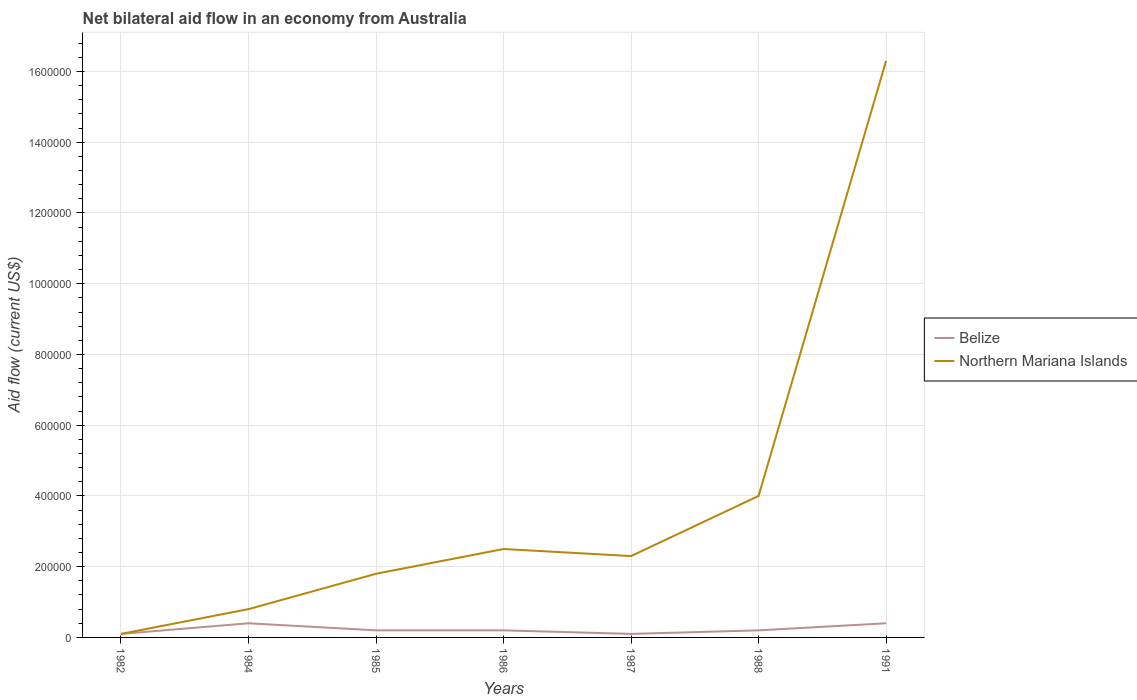How many different coloured lines are there?
Ensure brevity in your answer.  2. Is the number of lines equal to the number of legend labels?
Offer a very short reply. Yes. In which year was the net bilateral aid flow in Belize maximum?
Provide a succinct answer. 1982. What is the difference between the highest and the second highest net bilateral aid flow in Belize?
Provide a succinct answer. 3.00e+04. Is the net bilateral aid flow in Belize strictly greater than the net bilateral aid flow in Northern Mariana Islands over the years?
Your answer should be very brief. No. How many lines are there?
Offer a very short reply. 2. How many years are there in the graph?
Give a very brief answer. 7. Where does the legend appear in the graph?
Make the answer very short. Center right. How many legend labels are there?
Provide a short and direct response. 2. How are the legend labels stacked?
Ensure brevity in your answer.  Vertical. What is the title of the graph?
Provide a short and direct response. Net bilateral aid flow in an economy from Australia. Does "Romania" appear as one of the legend labels in the graph?
Your answer should be compact. No. What is the Aid flow (current US$) of Northern Mariana Islands in 1982?
Provide a succinct answer. 10000. What is the Aid flow (current US$) of Belize in 1984?
Your response must be concise. 4.00e+04. What is the Aid flow (current US$) of Belize in 1985?
Give a very brief answer. 2.00e+04. What is the Aid flow (current US$) of Belize in 1986?
Your answer should be compact. 2.00e+04. What is the Aid flow (current US$) of Northern Mariana Islands in 1986?
Your answer should be compact. 2.50e+05. What is the Aid flow (current US$) in Belize in 1987?
Make the answer very short. 10000. What is the Aid flow (current US$) in Northern Mariana Islands in 1987?
Offer a very short reply. 2.30e+05. What is the Aid flow (current US$) in Northern Mariana Islands in 1988?
Keep it short and to the point. 4.00e+05. What is the Aid flow (current US$) of Northern Mariana Islands in 1991?
Make the answer very short. 1.63e+06. Across all years, what is the maximum Aid flow (current US$) in Northern Mariana Islands?
Ensure brevity in your answer.  1.63e+06. Across all years, what is the minimum Aid flow (current US$) of Northern Mariana Islands?
Keep it short and to the point. 10000. What is the total Aid flow (current US$) of Northern Mariana Islands in the graph?
Provide a short and direct response. 2.78e+06. What is the difference between the Aid flow (current US$) of Northern Mariana Islands in 1982 and that in 1984?
Your answer should be very brief. -7.00e+04. What is the difference between the Aid flow (current US$) in Belize in 1982 and that in 1985?
Ensure brevity in your answer.  -10000. What is the difference between the Aid flow (current US$) in Belize in 1982 and that in 1986?
Your answer should be very brief. -10000. What is the difference between the Aid flow (current US$) in Northern Mariana Islands in 1982 and that in 1988?
Your response must be concise. -3.90e+05. What is the difference between the Aid flow (current US$) of Northern Mariana Islands in 1982 and that in 1991?
Provide a short and direct response. -1.62e+06. What is the difference between the Aid flow (current US$) of Northern Mariana Islands in 1984 and that in 1985?
Your response must be concise. -1.00e+05. What is the difference between the Aid flow (current US$) of Belize in 1984 and that in 1986?
Ensure brevity in your answer.  2.00e+04. What is the difference between the Aid flow (current US$) of Northern Mariana Islands in 1984 and that in 1988?
Keep it short and to the point. -3.20e+05. What is the difference between the Aid flow (current US$) of Northern Mariana Islands in 1984 and that in 1991?
Make the answer very short. -1.55e+06. What is the difference between the Aid flow (current US$) in Belize in 1985 and that in 1986?
Keep it short and to the point. 0. What is the difference between the Aid flow (current US$) of Northern Mariana Islands in 1985 and that in 1987?
Provide a short and direct response. -5.00e+04. What is the difference between the Aid flow (current US$) in Northern Mariana Islands in 1985 and that in 1988?
Keep it short and to the point. -2.20e+05. What is the difference between the Aid flow (current US$) of Belize in 1985 and that in 1991?
Ensure brevity in your answer.  -2.00e+04. What is the difference between the Aid flow (current US$) of Northern Mariana Islands in 1985 and that in 1991?
Your response must be concise. -1.45e+06. What is the difference between the Aid flow (current US$) in Belize in 1986 and that in 1987?
Give a very brief answer. 10000. What is the difference between the Aid flow (current US$) of Belize in 1986 and that in 1988?
Offer a very short reply. 0. What is the difference between the Aid flow (current US$) of Belize in 1986 and that in 1991?
Your response must be concise. -2.00e+04. What is the difference between the Aid flow (current US$) in Northern Mariana Islands in 1986 and that in 1991?
Offer a very short reply. -1.38e+06. What is the difference between the Aid flow (current US$) in Northern Mariana Islands in 1987 and that in 1988?
Give a very brief answer. -1.70e+05. What is the difference between the Aid flow (current US$) of Northern Mariana Islands in 1987 and that in 1991?
Your answer should be very brief. -1.40e+06. What is the difference between the Aid flow (current US$) in Northern Mariana Islands in 1988 and that in 1991?
Give a very brief answer. -1.23e+06. What is the difference between the Aid flow (current US$) of Belize in 1982 and the Aid flow (current US$) of Northern Mariana Islands in 1985?
Give a very brief answer. -1.70e+05. What is the difference between the Aid flow (current US$) of Belize in 1982 and the Aid flow (current US$) of Northern Mariana Islands in 1986?
Ensure brevity in your answer.  -2.40e+05. What is the difference between the Aid flow (current US$) in Belize in 1982 and the Aid flow (current US$) in Northern Mariana Islands in 1987?
Make the answer very short. -2.20e+05. What is the difference between the Aid flow (current US$) in Belize in 1982 and the Aid flow (current US$) in Northern Mariana Islands in 1988?
Make the answer very short. -3.90e+05. What is the difference between the Aid flow (current US$) of Belize in 1982 and the Aid flow (current US$) of Northern Mariana Islands in 1991?
Offer a terse response. -1.62e+06. What is the difference between the Aid flow (current US$) in Belize in 1984 and the Aid flow (current US$) in Northern Mariana Islands in 1986?
Keep it short and to the point. -2.10e+05. What is the difference between the Aid flow (current US$) of Belize in 1984 and the Aid flow (current US$) of Northern Mariana Islands in 1987?
Provide a succinct answer. -1.90e+05. What is the difference between the Aid flow (current US$) in Belize in 1984 and the Aid flow (current US$) in Northern Mariana Islands in 1988?
Your answer should be compact. -3.60e+05. What is the difference between the Aid flow (current US$) of Belize in 1984 and the Aid flow (current US$) of Northern Mariana Islands in 1991?
Give a very brief answer. -1.59e+06. What is the difference between the Aid flow (current US$) in Belize in 1985 and the Aid flow (current US$) in Northern Mariana Islands in 1988?
Make the answer very short. -3.80e+05. What is the difference between the Aid flow (current US$) in Belize in 1985 and the Aid flow (current US$) in Northern Mariana Islands in 1991?
Give a very brief answer. -1.61e+06. What is the difference between the Aid flow (current US$) of Belize in 1986 and the Aid flow (current US$) of Northern Mariana Islands in 1988?
Ensure brevity in your answer.  -3.80e+05. What is the difference between the Aid flow (current US$) of Belize in 1986 and the Aid flow (current US$) of Northern Mariana Islands in 1991?
Offer a terse response. -1.61e+06. What is the difference between the Aid flow (current US$) in Belize in 1987 and the Aid flow (current US$) in Northern Mariana Islands in 1988?
Offer a very short reply. -3.90e+05. What is the difference between the Aid flow (current US$) of Belize in 1987 and the Aid flow (current US$) of Northern Mariana Islands in 1991?
Ensure brevity in your answer.  -1.62e+06. What is the difference between the Aid flow (current US$) of Belize in 1988 and the Aid flow (current US$) of Northern Mariana Islands in 1991?
Keep it short and to the point. -1.61e+06. What is the average Aid flow (current US$) in Belize per year?
Your answer should be very brief. 2.29e+04. What is the average Aid flow (current US$) in Northern Mariana Islands per year?
Your response must be concise. 3.97e+05. In the year 1988, what is the difference between the Aid flow (current US$) of Belize and Aid flow (current US$) of Northern Mariana Islands?
Your answer should be very brief. -3.80e+05. In the year 1991, what is the difference between the Aid flow (current US$) in Belize and Aid flow (current US$) in Northern Mariana Islands?
Offer a terse response. -1.59e+06. What is the ratio of the Aid flow (current US$) in Northern Mariana Islands in 1982 to that in 1985?
Give a very brief answer. 0.06. What is the ratio of the Aid flow (current US$) in Northern Mariana Islands in 1982 to that in 1986?
Ensure brevity in your answer.  0.04. What is the ratio of the Aid flow (current US$) in Northern Mariana Islands in 1982 to that in 1987?
Your response must be concise. 0.04. What is the ratio of the Aid flow (current US$) in Northern Mariana Islands in 1982 to that in 1988?
Give a very brief answer. 0.03. What is the ratio of the Aid flow (current US$) in Northern Mariana Islands in 1982 to that in 1991?
Ensure brevity in your answer.  0.01. What is the ratio of the Aid flow (current US$) in Belize in 1984 to that in 1985?
Your answer should be compact. 2. What is the ratio of the Aid flow (current US$) in Northern Mariana Islands in 1984 to that in 1985?
Offer a terse response. 0.44. What is the ratio of the Aid flow (current US$) in Northern Mariana Islands in 1984 to that in 1986?
Your answer should be very brief. 0.32. What is the ratio of the Aid flow (current US$) of Northern Mariana Islands in 1984 to that in 1987?
Offer a very short reply. 0.35. What is the ratio of the Aid flow (current US$) of Northern Mariana Islands in 1984 to that in 1991?
Provide a succinct answer. 0.05. What is the ratio of the Aid flow (current US$) of Belize in 1985 to that in 1986?
Your answer should be very brief. 1. What is the ratio of the Aid flow (current US$) in Northern Mariana Islands in 1985 to that in 1986?
Offer a terse response. 0.72. What is the ratio of the Aid flow (current US$) of Northern Mariana Islands in 1985 to that in 1987?
Your response must be concise. 0.78. What is the ratio of the Aid flow (current US$) in Northern Mariana Islands in 1985 to that in 1988?
Give a very brief answer. 0.45. What is the ratio of the Aid flow (current US$) in Northern Mariana Islands in 1985 to that in 1991?
Offer a very short reply. 0.11. What is the ratio of the Aid flow (current US$) of Northern Mariana Islands in 1986 to that in 1987?
Make the answer very short. 1.09. What is the ratio of the Aid flow (current US$) of Northern Mariana Islands in 1986 to that in 1988?
Make the answer very short. 0.62. What is the ratio of the Aid flow (current US$) of Northern Mariana Islands in 1986 to that in 1991?
Give a very brief answer. 0.15. What is the ratio of the Aid flow (current US$) of Northern Mariana Islands in 1987 to that in 1988?
Provide a succinct answer. 0.57. What is the ratio of the Aid flow (current US$) in Belize in 1987 to that in 1991?
Offer a very short reply. 0.25. What is the ratio of the Aid flow (current US$) of Northern Mariana Islands in 1987 to that in 1991?
Keep it short and to the point. 0.14. What is the ratio of the Aid flow (current US$) in Belize in 1988 to that in 1991?
Offer a very short reply. 0.5. What is the ratio of the Aid flow (current US$) in Northern Mariana Islands in 1988 to that in 1991?
Keep it short and to the point. 0.25. What is the difference between the highest and the second highest Aid flow (current US$) in Northern Mariana Islands?
Your answer should be very brief. 1.23e+06. What is the difference between the highest and the lowest Aid flow (current US$) in Northern Mariana Islands?
Your answer should be very brief. 1.62e+06. 